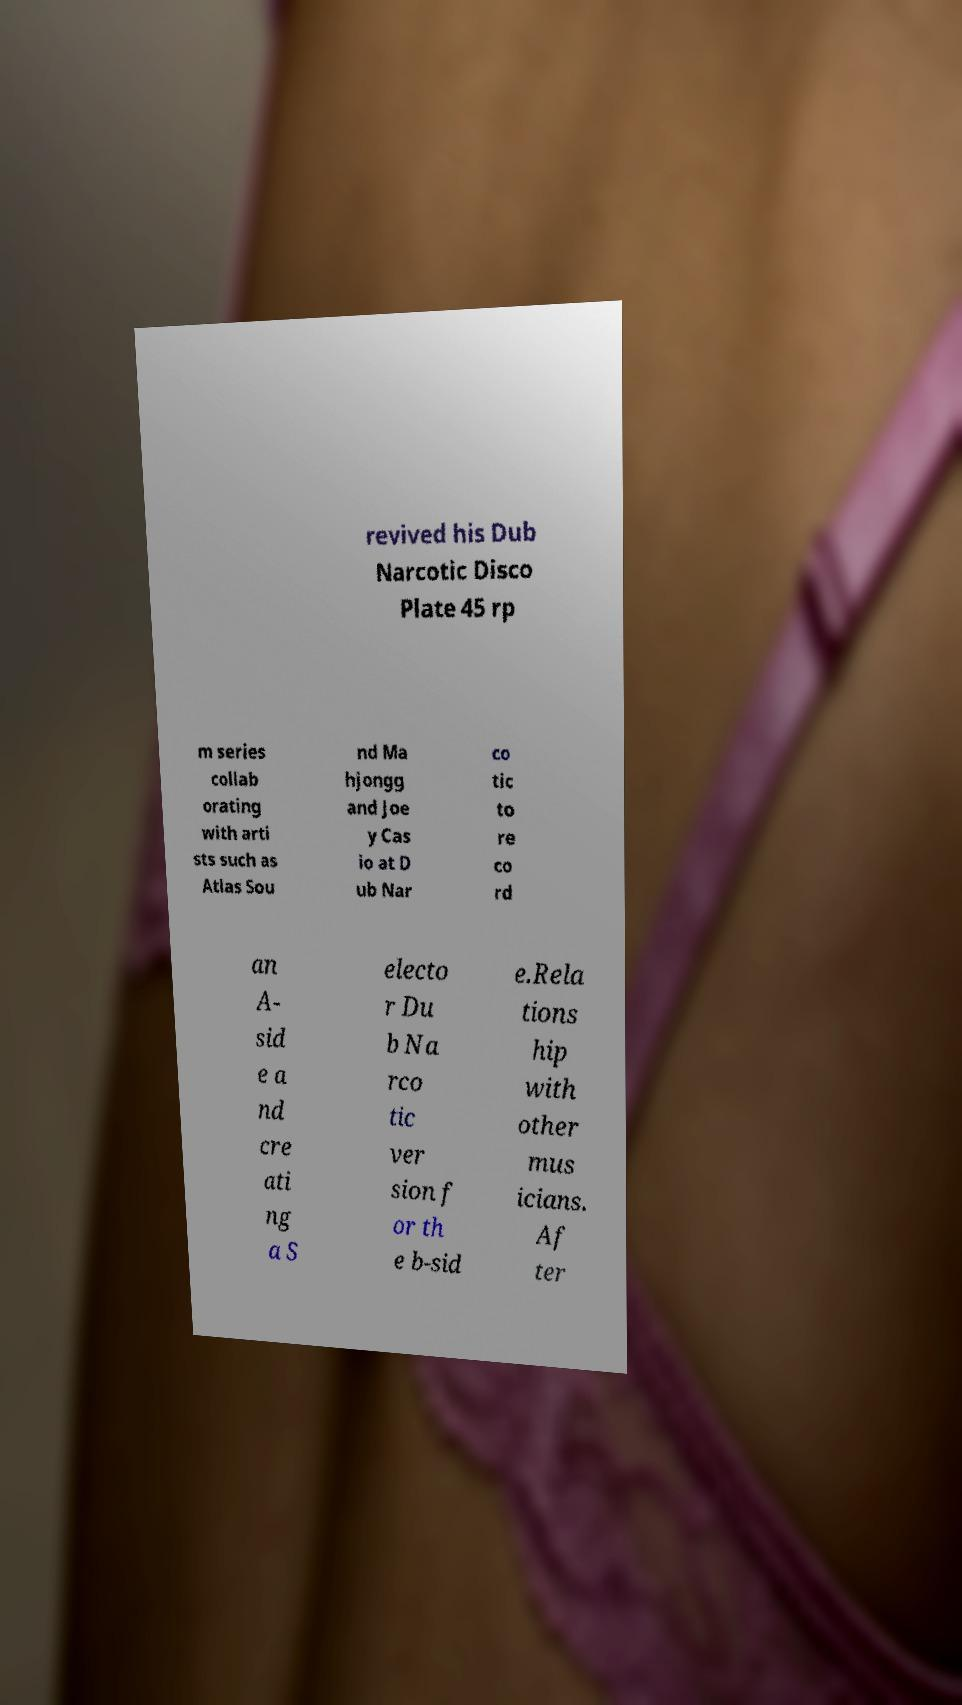Could you assist in decoding the text presented in this image and type it out clearly? revived his Dub Narcotic Disco Plate 45 rp m series collab orating with arti sts such as Atlas Sou nd Ma hjongg and Joe y Cas io at D ub Nar co tic to re co rd an A- sid e a nd cre ati ng a S electo r Du b Na rco tic ver sion f or th e b-sid e.Rela tions hip with other mus icians. Af ter 